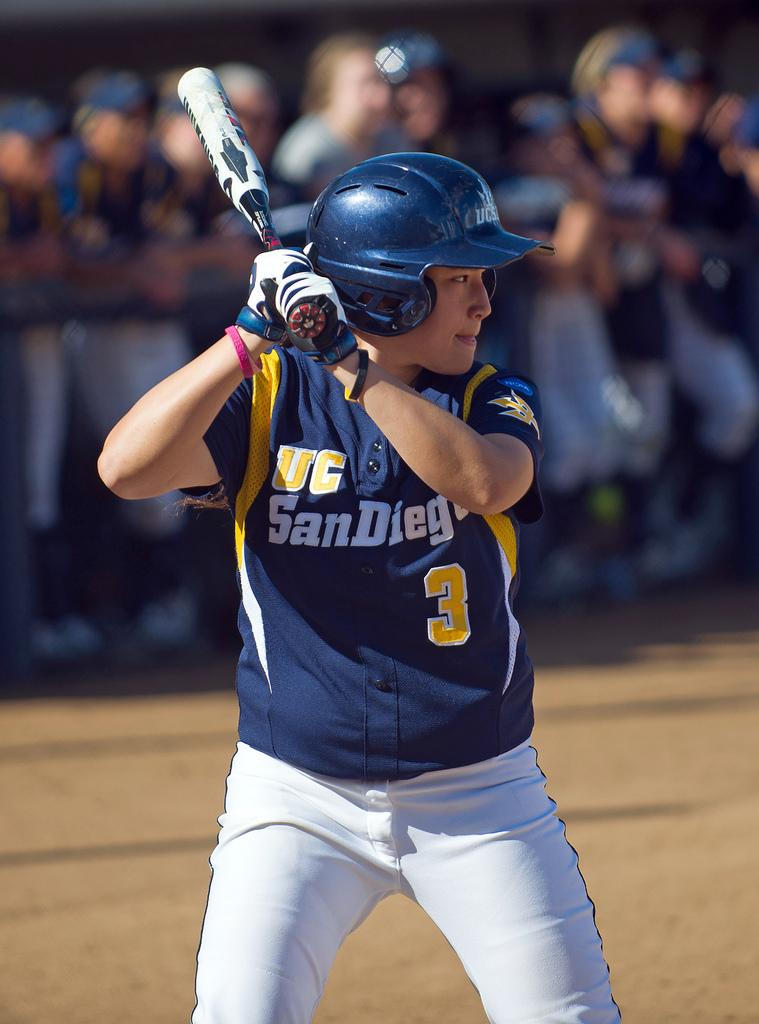How many people are in the image? There is a group of people in the image. What can be seen in the background of the image? There is fencing in the image. What activity might the person holding a baseball stick be participating in? The person holding a baseball stick might be participating in a game of baseball. What type of straw is the squirrel holding in the image? There is no squirrel or straw present in the image. 